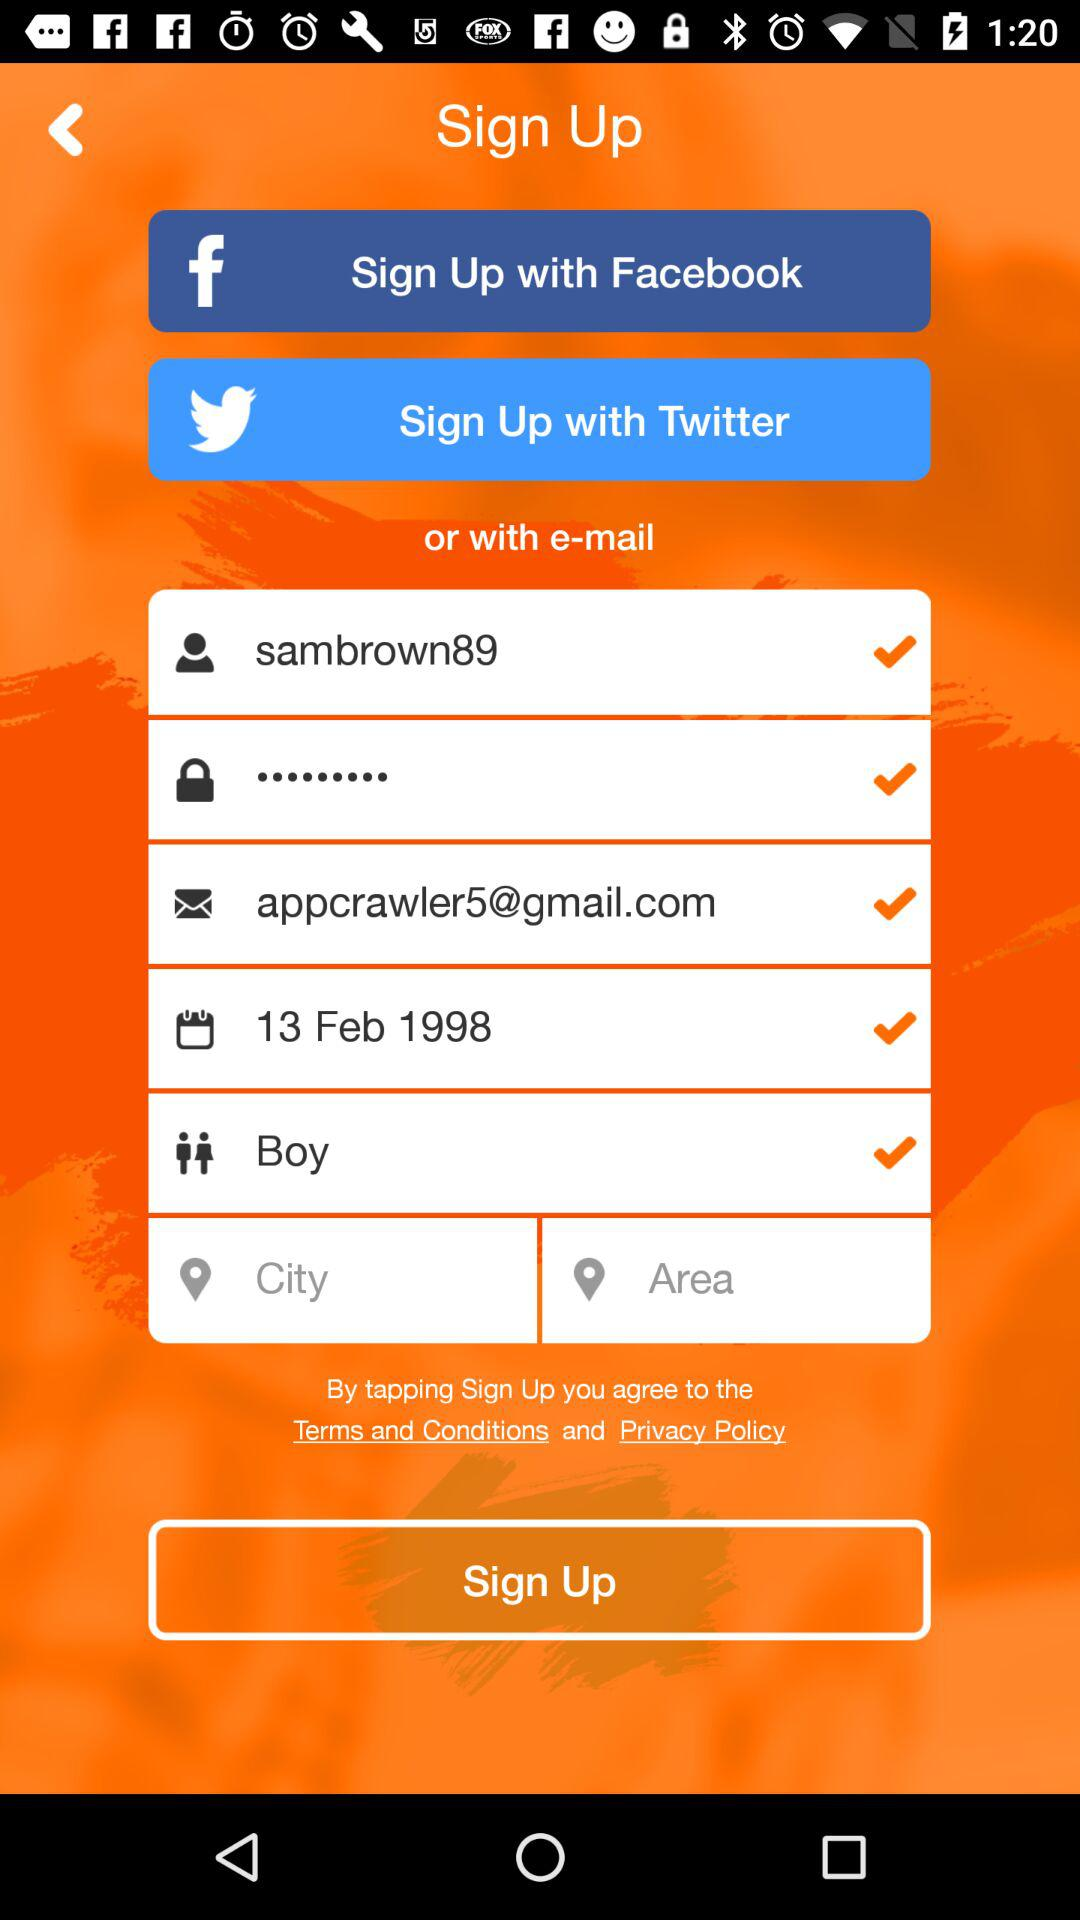What is the entered date of birth? The entered date of birth is February 13, 1998. 